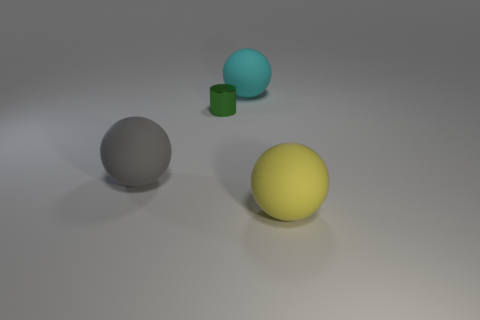Is the number of big cyan rubber spheres less than the number of blue metal balls?
Your answer should be very brief. No. Is the number of big cyan things greater than the number of red rubber things?
Keep it short and to the point. Yes. The yellow object that is the same shape as the large cyan matte object is what size?
Make the answer very short. Large. Is the gray object made of the same material as the object that is right of the cyan matte ball?
Offer a very short reply. Yes. What number of objects are either big spheres or large brown metal cylinders?
Offer a terse response. 3. Does the ball to the left of the small green thing have the same size as the matte thing behind the cylinder?
Give a very brief answer. Yes. What number of cubes are either cyan things or large gray rubber objects?
Provide a succinct answer. 0. Are any small green shiny cylinders visible?
Offer a terse response. Yes. Is there anything else that has the same shape as the small green metallic object?
Offer a very short reply. No. How many things are spheres behind the green metal cylinder or large cyan matte objects?
Keep it short and to the point. 1. 